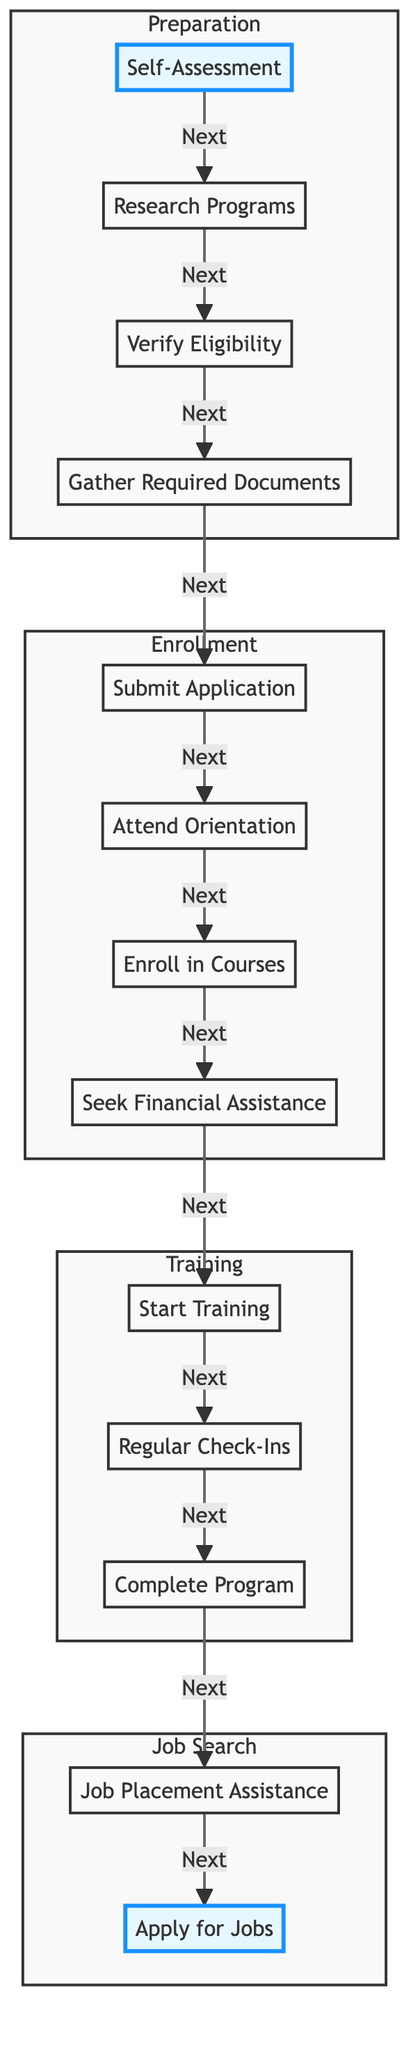What is the first step in the enrollment process? The first step in the diagram is labeled "Self-Assessment". It is indicated as the starting point of the flowchart and leads to the next step.
Answer: Self-Assessment How many main sections are there in the flowchart? The flowchart contains four main sections: Preparation, Enrollment, Training, and Job Search. Each section is clearly delineated with specific steps related to that phase.
Answer: Four What follows after "Gather Required Documents"? After "Gather Required Documents", the next step indicated in the flowchart is "Submit Application". This shows the progression of actions that need to be taken for enrollment.
Answer: Submit Application Which step comes just before "Start Training"? The step that comes just before "Start Training" is "Seek Financial Assistance". This step is highlighted to show it is an important action to take prior to starting the training program.
Answer: Seek Financial Assistance What is the last step in the diagram? The last step in the flowchart is labeled "Apply for Jobs". This step concludes the process by encouraging the individual to seek employment after completing the retraining program.
Answer: Apply for Jobs How many steps are there in the entire process? The entire process consists of thirteen steps, starting from "Self-Assessment" and ending with "Apply for Jobs". Each step contributes to the overall enrollment procedure for job retraining.
Answer: Thirteen What is the purpose of the "Regular Check-Ins" step? The purpose of "Regular Check-Ins" is to maintain contact with program advisors or counselors, which ensures tracking of progress and obtaining additional support during the training process.
Answer: Support Which section includes the step "Attend Orientation"? "Attend Orientation" is included in the Enrollment section. It is a critical step that informs participants about the program structure and expectations.
Answer: Enrollment What type of assistance can be sought after enrolling in courses? After enrolling in courses, individuals can seek "Financial Assistance" such as grants, scholarships, or loans to support their training financially.
Answer: Financial Assistance 